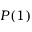Convert formula to latex. <formula><loc_0><loc_0><loc_500><loc_500>P ( 1 )</formula> 